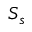<formula> <loc_0><loc_0><loc_500><loc_500>S _ { s }</formula> 